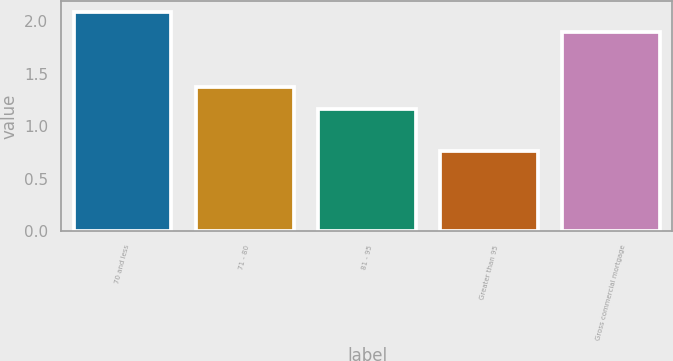Convert chart to OTSL. <chart><loc_0><loc_0><loc_500><loc_500><bar_chart><fcel>70 and less<fcel>71 - 80<fcel>81 - 95<fcel>Greater than 95<fcel>Gross commercial mortgage<nl><fcel>2.09<fcel>1.37<fcel>1.16<fcel>0.76<fcel>1.9<nl></chart> 